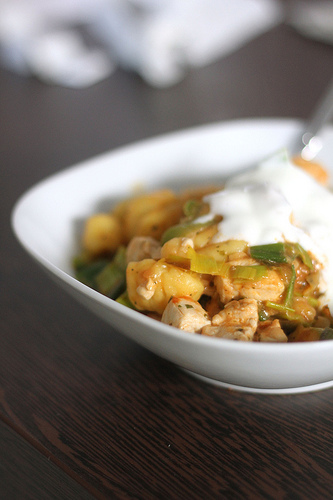<image>
Can you confirm if the food is above the wood? Yes. The food is positioned above the wood in the vertical space, higher up in the scene. 